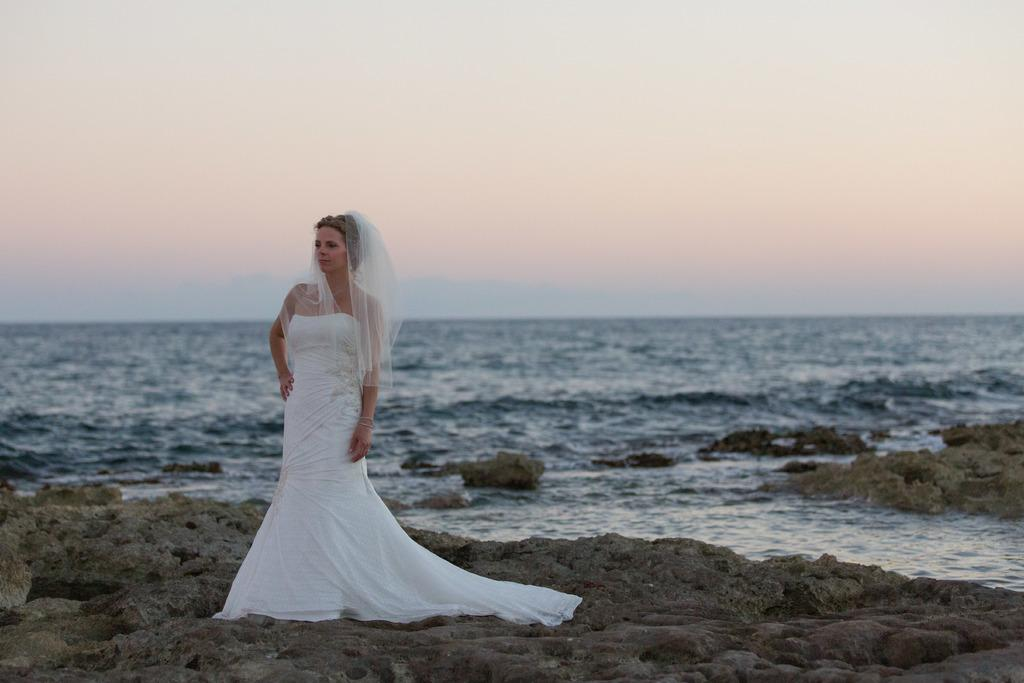What is the main subject of the image? The main subject of the image is a bride. What is the bride's position in the image? The bride is on the ground. What natural element is visible in the image? Water is visible in the image. What part of the natural environment is visible in the image? The sky is visible in the image. What type of hen can be seen in the image? There is no hen present in the image. What color is the donkey in the image? There is no donkey present in the image. How many oranges can be seen in the image? There are no oranges present in the image. 